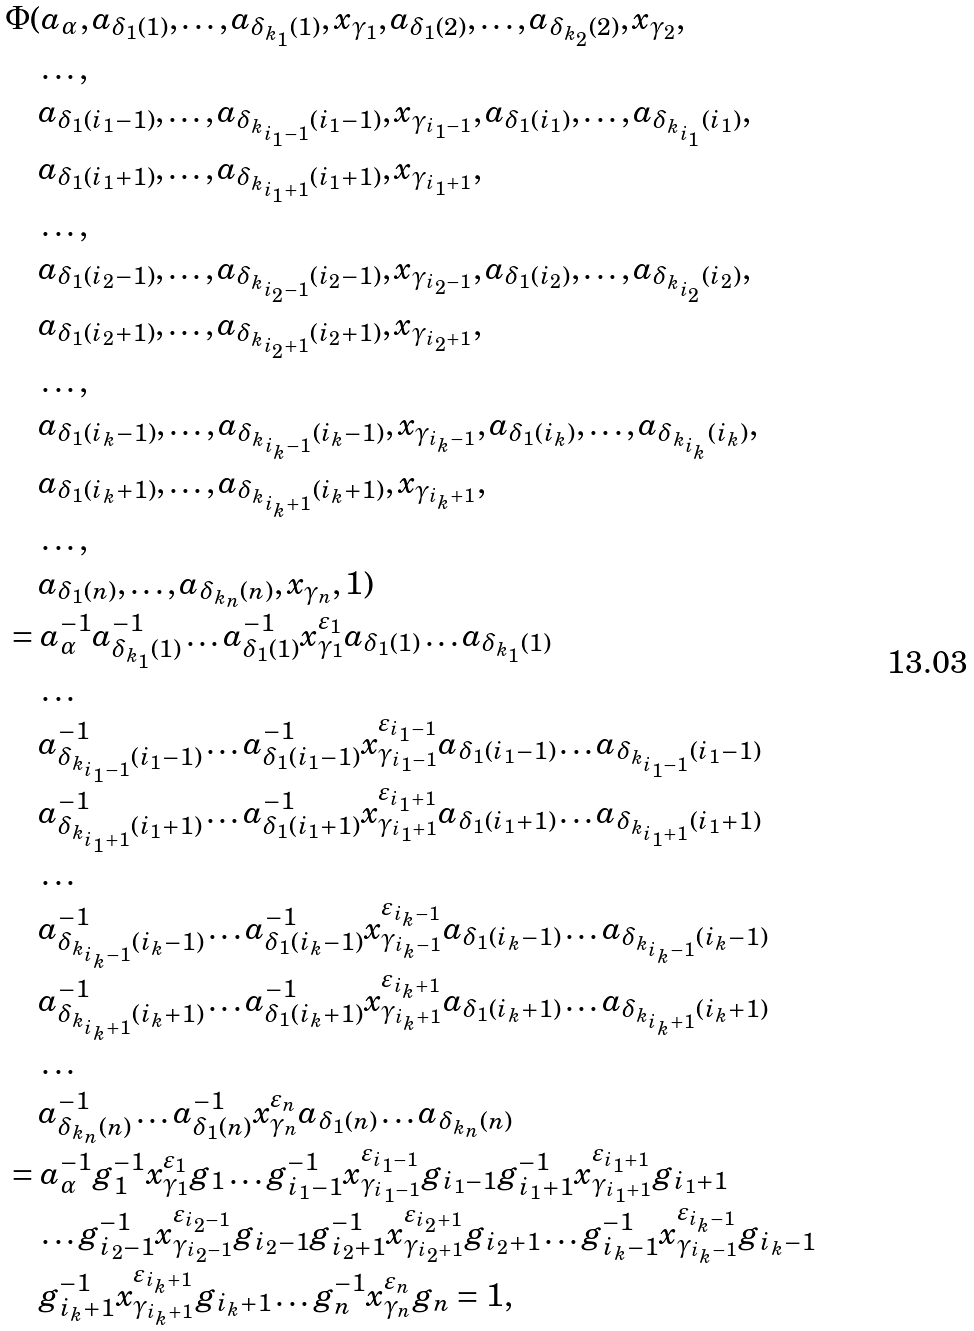<formula> <loc_0><loc_0><loc_500><loc_500>& \Phi ( a _ { \alpha } , a _ { \delta _ { 1 } ( 1 ) } , \dots , a _ { \delta _ { k _ { 1 } } ( 1 ) } , x _ { \gamma _ { 1 } } , a _ { \delta _ { 1 } ( 2 ) } , \dots , a _ { \delta _ { k _ { 2 } } ( 2 ) } , x _ { \gamma _ { 2 } } , \\ & \quad \dots , \\ & \quad a _ { \delta _ { 1 } ( i _ { 1 } - 1 ) } , \dots , a _ { \delta _ { k _ { i _ { 1 } - 1 } } ( i _ { 1 } - 1 ) } , x _ { \gamma _ { i _ { 1 } - 1 } } , a _ { \delta _ { 1 } ( i _ { 1 } ) } , \dots , a _ { \delta _ { k _ { i _ { 1 } } } ( i _ { 1 } ) } , \\ & \quad a _ { \delta _ { 1 } ( i _ { 1 } + 1 ) } , \dots , a _ { \delta _ { k _ { i _ { 1 } + 1 } } ( i _ { 1 } + 1 ) } , x _ { \gamma _ { i _ { 1 } + 1 } } , \\ & \quad \dots , \\ & \quad a _ { \delta _ { 1 } ( i _ { 2 } - 1 ) } , \dots , a _ { \delta _ { k _ { i _ { 2 } - 1 } } ( i _ { 2 } - 1 ) } , x _ { \gamma _ { i _ { 2 } - 1 } } , a _ { \delta _ { 1 } ( i _ { 2 } ) } , \dots , a _ { \delta _ { k _ { i _ { 2 } } } ( i _ { 2 } ) } , \\ & \quad a _ { \delta _ { 1 } ( i _ { 2 } + 1 ) } , \dots , a _ { \delta _ { k _ { i _ { 2 } + 1 } } ( i _ { 2 } + 1 ) } , x _ { \gamma _ { i _ { 2 } + 1 } } , \\ & \quad \dots , \\ & \quad a _ { \delta _ { 1 } ( i _ { k } - 1 ) } , \dots , a _ { \delta _ { k _ { i _ { k } - 1 } } ( i _ { k } - 1 ) } , x _ { \gamma _ { i _ { k } - 1 } } , a _ { \delta _ { 1 } ( i _ { k } ) } , \dots , a _ { \delta _ { k _ { i _ { k } } } ( i _ { k } ) } , \\ & \quad a _ { \delta _ { 1 } ( i _ { k } + 1 ) } , \dots , a _ { \delta _ { k _ { i _ { k } + 1 } } ( i _ { k } + 1 ) } , x _ { \gamma _ { i _ { k } + 1 } } , \\ & \quad \dots , \\ & \quad a _ { \delta _ { 1 } ( n ) } , \dots , a _ { \delta _ { k _ { n } } ( n ) } , x _ { \gamma _ { n } } , 1 ) \\ & = a _ { \alpha } ^ { - 1 } a _ { \delta _ { k _ { 1 } } ( 1 ) } ^ { - 1 } \dots a _ { \delta _ { 1 } ( 1 ) } ^ { - 1 } x _ { \gamma _ { 1 } } ^ { \varepsilon _ { 1 } } a _ { \delta _ { 1 } ( 1 ) } \dots a _ { \delta _ { k _ { 1 } } ( 1 ) } \\ & \quad \dots \\ & \quad a _ { \delta _ { k _ { i _ { 1 } - 1 } } ( i _ { 1 } - 1 ) } ^ { - 1 } \dots a _ { \delta _ { 1 } ( i _ { 1 } - 1 ) } ^ { - 1 } x _ { \gamma _ { i _ { 1 } - 1 } } ^ { \varepsilon _ { i _ { 1 } - 1 } } a _ { \delta _ { 1 } ( i _ { 1 } - 1 ) } \dots a _ { \delta _ { k _ { i _ { 1 } - 1 } } ( i _ { 1 } - 1 ) } \\ & \quad a _ { \delta _ { k _ { i _ { 1 } + 1 } } ( i _ { 1 } + 1 ) } ^ { - 1 } \dots a _ { \delta _ { 1 } ( i _ { 1 } + 1 ) } ^ { - 1 } x _ { \gamma _ { i _ { 1 } + 1 } } ^ { \varepsilon _ { i _ { 1 } + 1 } } a _ { \delta _ { 1 } ( i _ { 1 } + 1 ) } \dots a _ { \delta _ { k _ { i _ { 1 } + 1 } } ( i _ { 1 } + 1 ) } \\ & \quad \dots \\ & \quad a _ { \delta _ { k _ { i _ { k } - 1 } } ( i _ { k } - 1 ) } ^ { - 1 } \dots a _ { \delta _ { 1 } ( i _ { k } - 1 ) } ^ { - 1 } x _ { \gamma _ { i _ { k } - 1 } } ^ { \varepsilon _ { i _ { k } - 1 } } a _ { \delta _ { 1 } ( i _ { k } - 1 ) } \dots a _ { \delta _ { k _ { i _ { k } - 1 } } ( i _ { k } - 1 ) } \\ & \quad a _ { \delta _ { k _ { i _ { k } + 1 } } ( i _ { k } + 1 ) } ^ { - 1 } \dots a _ { \delta _ { 1 } ( i _ { k } + 1 ) } ^ { - 1 } x _ { \gamma _ { i _ { k } + 1 } } ^ { \varepsilon _ { i _ { k } + 1 } } a _ { \delta _ { 1 } ( i _ { k } + 1 ) } \dots a _ { \delta _ { k _ { i _ { k } + 1 } } ( i _ { k } + 1 ) } \\ & \quad \dots \\ & \quad a _ { \delta _ { k _ { n } } ( n ) } ^ { - 1 } \dots a _ { \delta _ { 1 } ( n ) } ^ { - 1 } x _ { \gamma _ { n } } ^ { \varepsilon _ { n } } a _ { \delta _ { 1 } ( n ) } \dots a _ { \delta _ { k _ { n } } ( n ) } \\ & = a _ { \alpha } ^ { - 1 } g _ { 1 } ^ { - 1 } x _ { \gamma _ { 1 } } ^ { \varepsilon _ { 1 } } g _ { 1 } \dots g _ { i _ { 1 } - 1 } ^ { - 1 } x _ { \gamma _ { i _ { 1 } - 1 } } ^ { \varepsilon _ { i _ { 1 } - 1 } } g _ { i _ { 1 } - 1 } g _ { i _ { 1 } + 1 } ^ { - 1 } x _ { \gamma _ { i _ { 1 } + 1 } } ^ { \varepsilon _ { i _ { 1 } + 1 } } g _ { i _ { 1 } + 1 } \\ & \quad \dots g _ { i _ { 2 } - 1 } ^ { - 1 } x _ { \gamma _ { i _ { 2 } - 1 } } ^ { \varepsilon _ { i _ { 2 } - 1 } } g _ { i _ { 2 } - 1 } g _ { i _ { 2 } + 1 } ^ { - 1 } x _ { \gamma _ { i _ { 2 } + 1 } } ^ { \varepsilon _ { i _ { 2 } + 1 } } g _ { i _ { 2 } + 1 } \dots g _ { i _ { k } - 1 } ^ { - 1 } x _ { \gamma _ { i _ { k } - 1 } } ^ { \varepsilon _ { i _ { k } - 1 } } g _ { i _ { k } - 1 } \\ & \quad g _ { i _ { k } + 1 } ^ { - 1 } x _ { \gamma _ { i _ { k } + 1 } } ^ { \varepsilon _ { i _ { k } + 1 } } g _ { i _ { k } + 1 } \dots g _ { n } ^ { - 1 } x _ { \gamma _ { n } } ^ { \varepsilon _ { n } } g _ { n } = 1 ,</formula> 